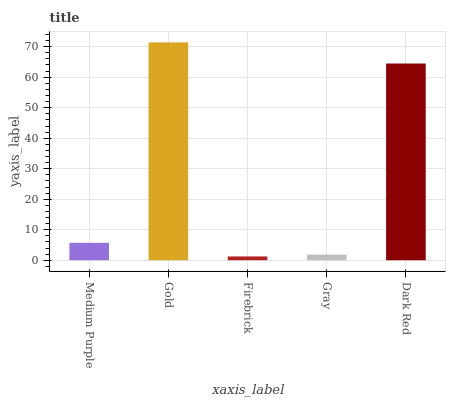Is Gold the minimum?
Answer yes or no. No. Is Firebrick the maximum?
Answer yes or no. No. Is Gold greater than Firebrick?
Answer yes or no. Yes. Is Firebrick less than Gold?
Answer yes or no. Yes. Is Firebrick greater than Gold?
Answer yes or no. No. Is Gold less than Firebrick?
Answer yes or no. No. Is Medium Purple the high median?
Answer yes or no. Yes. Is Medium Purple the low median?
Answer yes or no. Yes. Is Dark Red the high median?
Answer yes or no. No. Is Gold the low median?
Answer yes or no. No. 